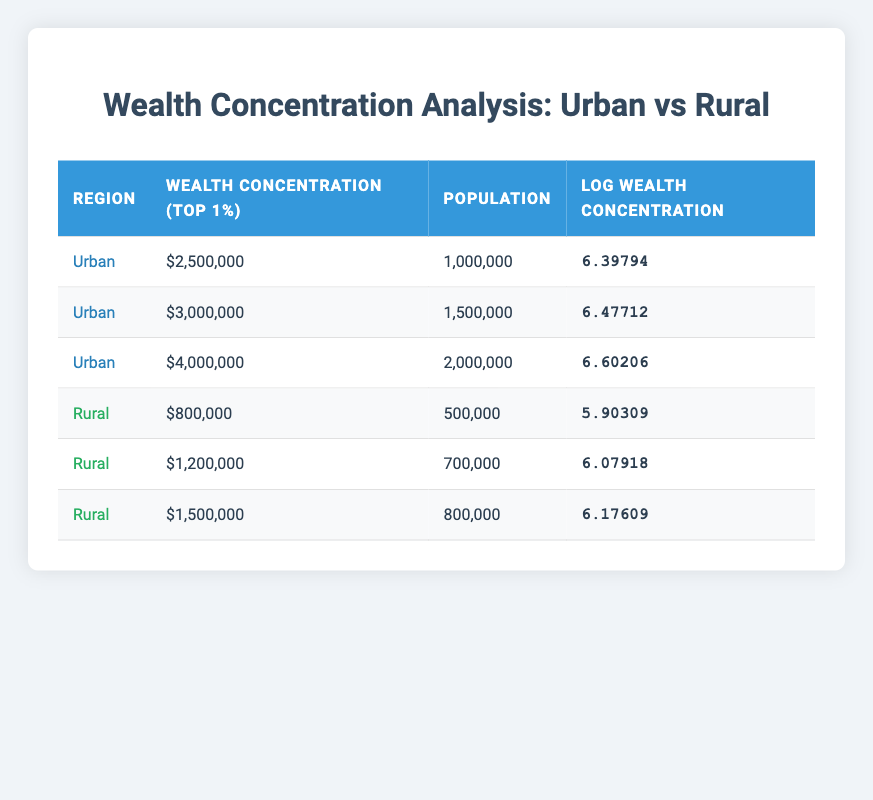What is the wealth concentration of the top 1 percent in urban areas for the highest recorded value in the table? The highest wealth concentration for the top 1 percent in urban areas is $4,000,000, which can be found in the third row under the urban section of the table.
Answer: 4,000,000 What is the population of the rural area with the lowest wealth concentration of the top 1 percent? The lowest wealth concentration in the rural area is $800,000, which corresponds to a population of 500,000 found in the fourth row.
Answer: 500,000 What is the average wealth concentration of the top 1 percent in rural areas? The wealth concentrations for rural areas are $800,000, $1,200,000, and $1,500,000. To find the average, sum these values: 800,000 + 1,200,000 + 1,500,000 = 3,500,000. Then divide by the number of data points (3): 3,500,000 / 3 = 1,166,666.67.
Answer: 1,166,666.67 Is the wealth concentration of the top 1 percent in urban areas always higher than in rural areas? Comparing the highest urban value of $4,000,000 with the highest rural value of $1,500,000 confirms that the urban concentration is greater. Therefore, it is true that urban areas have a higher concentration of wealth compared to rural areas.
Answer: Yes What is the difference in the log wealth concentration between the highest urban and the highest rural areas? The highest log wealth concentration in urban areas is 6.60206, and in rural areas, it is 6.17609. To find the difference, subtract the rural log from the urban log: 6.60206 - 6.17609 = 0.42597.
Answer: 0.42597 What percentage of the population lives in urban areas compared to the total population of both rural and urban areas combined? The total population of urban areas is 1,000,000 + 1,500,000 + 2,000,000 = 4,500,000. For rural areas, the total is 500,000 + 700,000 + 800,000 = 2,000,000. The combined total is 4,500,000 + 2,000,000 = 6,500,000. The percentage of the urban population is (4,500,000 / 6,500,000) * 100 = 69.23%.
Answer: 69.23% What is the wealth concentration of the top 1 percent in rural areas for the second-to-highest recorded value? The second-to-highest wealth concentration in rural areas is $1,200,000, which appears in the fifth row of the rural section.
Answer: 1,200,000 Is there more than one urban entry in the table? There are three entries (rows) for Urban in the table. Therefore, it is true that there is more than one urban entry.
Answer: Yes What is the median wealth concentration of the top 1 percent in urban areas? The urban wealth concentrations are $2,500,000, $3,000,000, and $4,000,000. To find the median, order the values: $2,500,000, $3,000,000, $4,000,000. The median is the middle value, so it is $3,000,000.
Answer: 3,000,000 